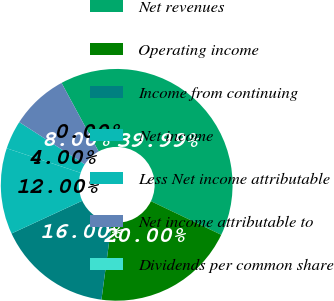Convert chart. <chart><loc_0><loc_0><loc_500><loc_500><pie_chart><fcel>Net revenues<fcel>Operating income<fcel>Income from continuing<fcel>Net income<fcel>Less Net income attributable<fcel>Net income attributable to<fcel>Dividends per common share<nl><fcel>39.99%<fcel>20.0%<fcel>16.0%<fcel>12.0%<fcel>4.0%<fcel>8.0%<fcel>0.0%<nl></chart> 